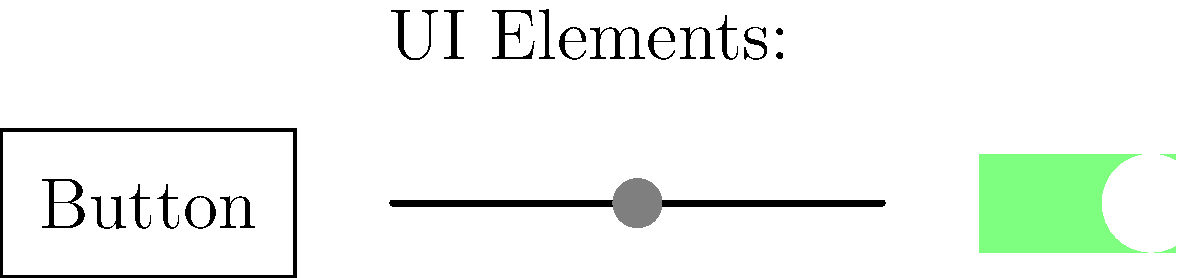In the image above, three common iOS UI elements are depicted. Which machine learning approach would be most suitable for classifying these elements in a larger dataset of UI screenshots, and why? To classify iOS UI elements in screenshots, we should consider the following steps:

1. Problem type: This is an image classification task, where we need to identify and categorize different UI elements.

2. Data characteristics:
   - UI elements have distinct visual features (shapes, colors, sizes)
   - The elements are relatively simple and have consistent appearances
   - We're dealing with 2D images

3. Suitable ML approach: Convolutional Neural Networks (CNNs) would be the most appropriate choice for this task because:
   - CNNs are designed specifically for image processing tasks
   - They can automatically learn hierarchical features from images
   - CNNs are translation-invariant, which is useful for detecting UI elements in different locations

4. CNN advantages for this task:
   - Feature extraction: CNNs can learn to detect edges, shapes, and more complex patterns specific to UI elements
   - Spatial relationships: They preserve spatial relationships between pixels, which is crucial for recognizing UI layouts
   - Robustness: CNNs can handle variations in size, position, and small design differences in UI elements

5. Implementation considerations:
   - Dataset: Collect a large dataset of iOS UI screenshots with labeled elements
   - Preprocessing: Normalize images and possibly augment the dataset
   - Architecture: Use a standard CNN architecture (e.g., ResNet, VGG) or design a custom one
   - Transfer learning: Consider using a pre-trained model and fine-tuning it for this specific task

6. Alternative approaches:
   - Traditional computer vision techniques might work but would require manual feature engineering
   - Other ML algorithms (e.g., SVMs, Random Forests) could be used but wouldn't be as effective for image data

In conclusion, CNNs offer the best combination of performance, feature learning capability, and suitability for image-based tasks, making them ideal for classifying iOS UI elements.
Answer: Convolutional Neural Networks (CNNs) 